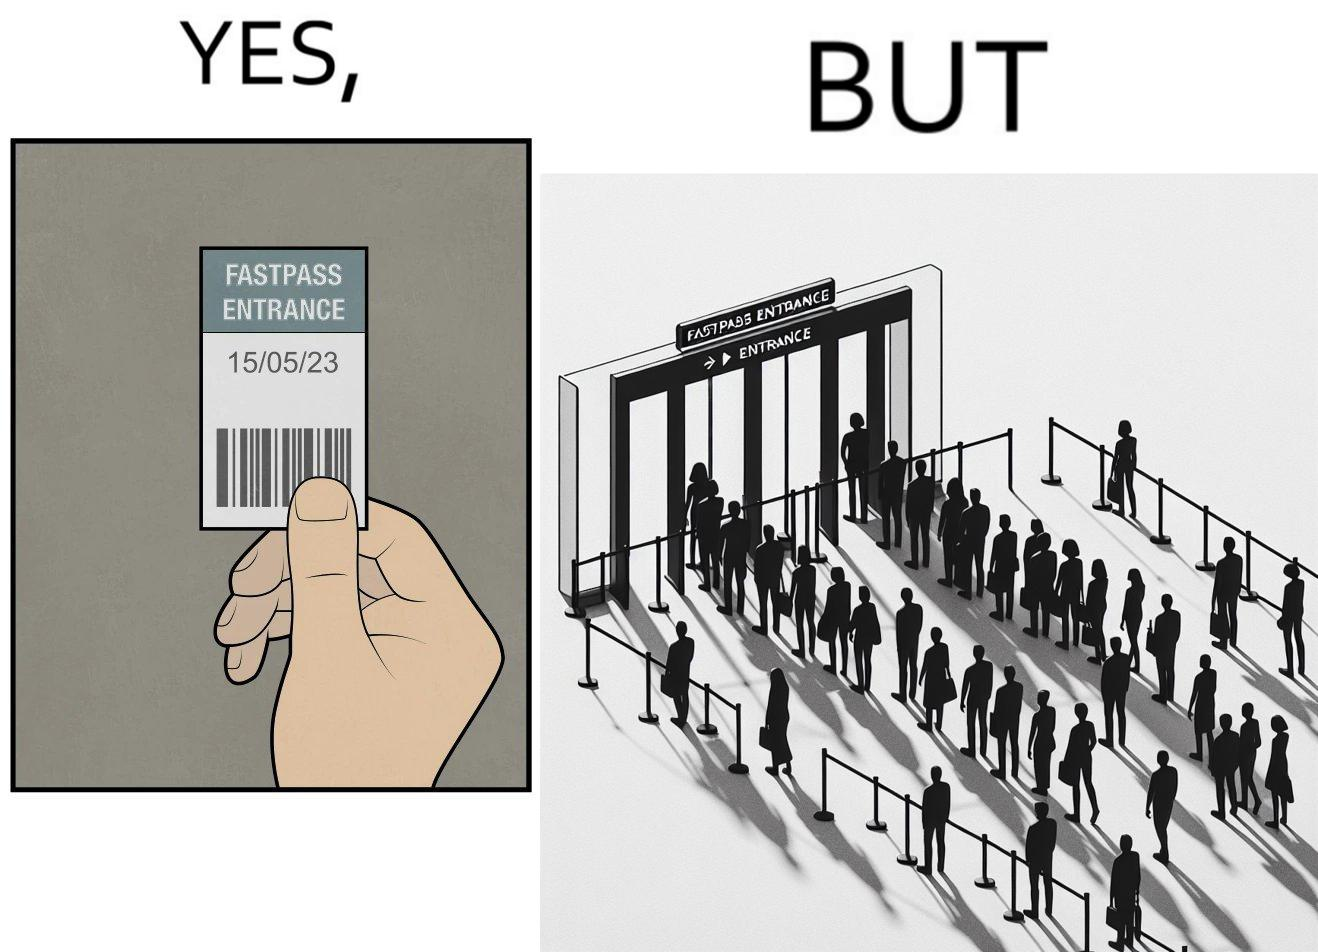Would you classify this image as satirical? Yes, this image is satirical. 